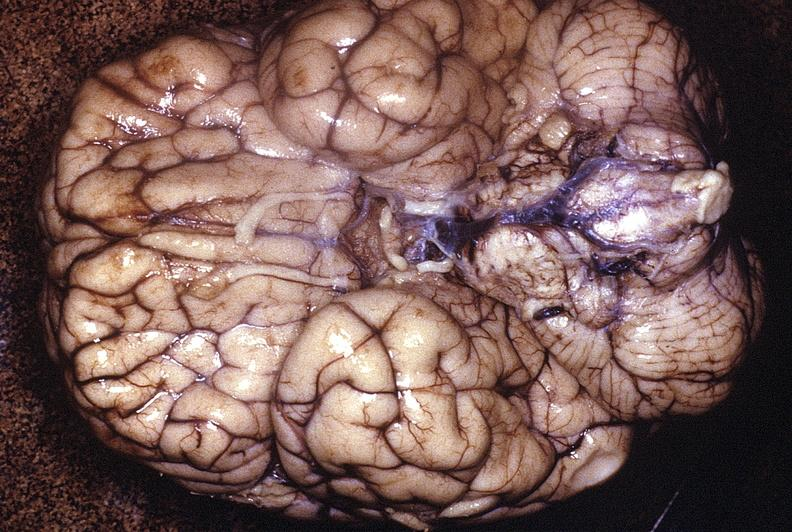what is present?
Answer the question using a single word or phrase. Nervous 